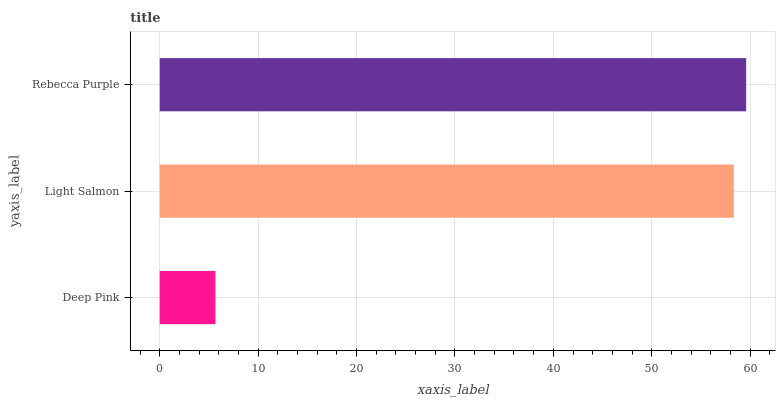Is Deep Pink the minimum?
Answer yes or no. Yes. Is Rebecca Purple the maximum?
Answer yes or no. Yes. Is Light Salmon the minimum?
Answer yes or no. No. Is Light Salmon the maximum?
Answer yes or no. No. Is Light Salmon greater than Deep Pink?
Answer yes or no. Yes. Is Deep Pink less than Light Salmon?
Answer yes or no. Yes. Is Deep Pink greater than Light Salmon?
Answer yes or no. No. Is Light Salmon less than Deep Pink?
Answer yes or no. No. Is Light Salmon the high median?
Answer yes or no. Yes. Is Light Salmon the low median?
Answer yes or no. Yes. Is Deep Pink the high median?
Answer yes or no. No. Is Rebecca Purple the low median?
Answer yes or no. No. 